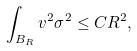Convert formula to latex. <formula><loc_0><loc_0><loc_500><loc_500>\int _ { B _ { R } } v ^ { 2 } \sigma ^ { 2 } \leq C R ^ { 2 } ,</formula> 